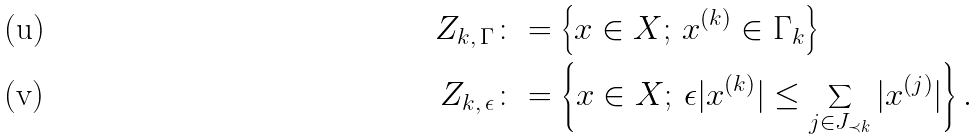Convert formula to latex. <formula><loc_0><loc_0><loc_500><loc_500>Z _ { k , \, \Gamma } & \colon = \left \{ x \in X ; \, x ^ { ( k ) } \in \Gamma _ { k } \right \} \\ Z _ { k , \, \epsilon } & \colon = \left \{ x \in X ; \, \epsilon | x ^ { ( k ) } | \leq \sum _ { j \in J _ { \prec k } } | x ^ { ( j ) } | \right \} .</formula> 